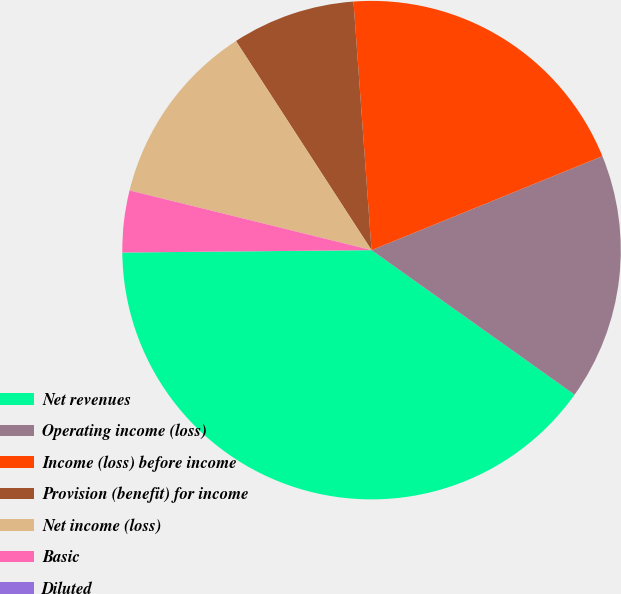<chart> <loc_0><loc_0><loc_500><loc_500><pie_chart><fcel>Net revenues<fcel>Operating income (loss)<fcel>Income (loss) before income<fcel>Provision (benefit) for income<fcel>Net income (loss)<fcel>Basic<fcel>Diluted<nl><fcel>40.0%<fcel>16.0%<fcel>20.0%<fcel>8.0%<fcel>12.0%<fcel>4.0%<fcel>0.0%<nl></chart> 